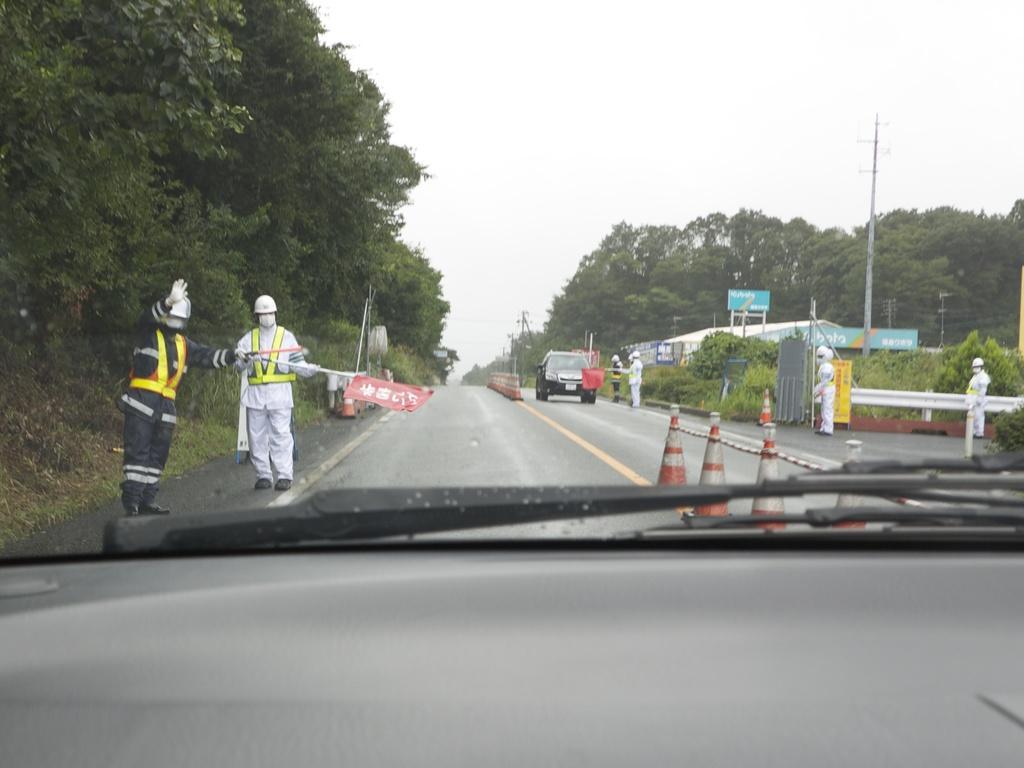Could you give a brief overview of what you see in this image? In the center of the image there is a car. There are persons holding flag. To the left side of the image there are trees. To the right side of the image there are electric poles. At the center of the image there is road. There are safety cones in the image. 